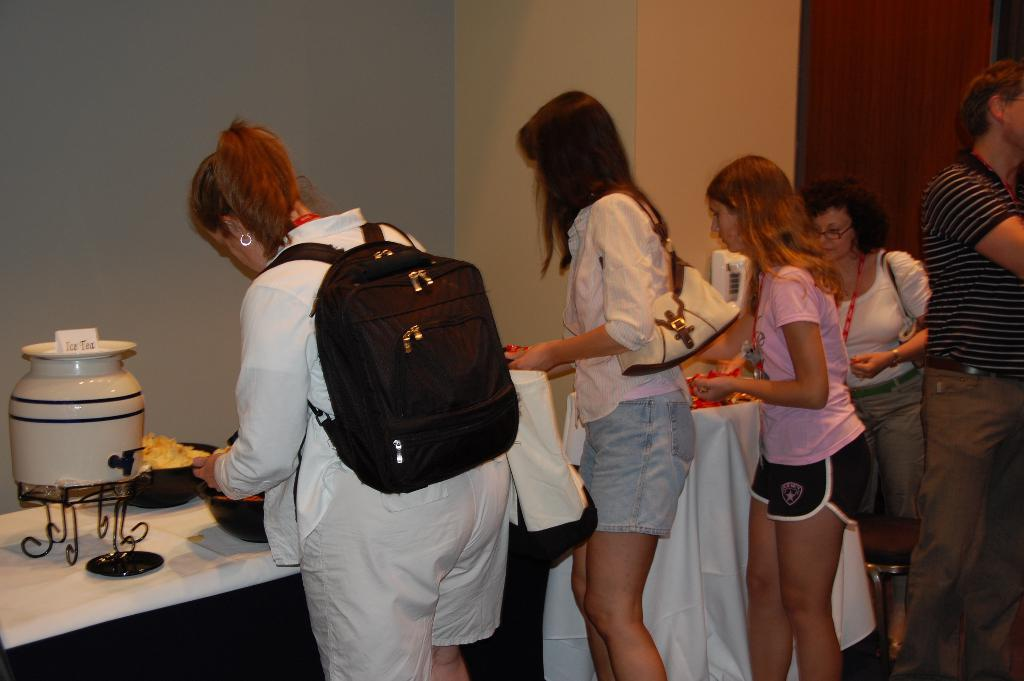Who is present in the image? There are women standing in front of a table, and there is a man standing on the right side of the image. What is on the table? The table has food bowls on it, and there is a jar on the table. What can be seen in the background of the image? There is a wall in the background. What does the mom say to the man in the image? There is no mention of a mom in the image, so we cannot determine what she might say to the man. 